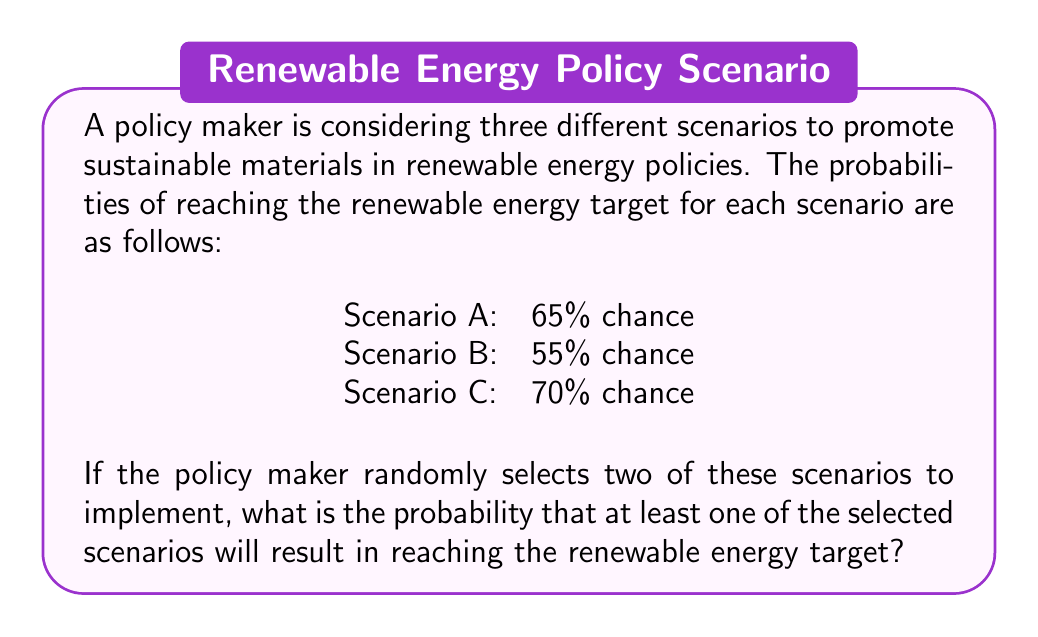Teach me how to tackle this problem. To solve this problem, we need to use the concept of probability of at least one event occurring.

1. First, let's calculate the probability of failure for each scenario:
   Scenario A: $1 - 0.65 = 0.35$
   Scenario B: $1 - 0.55 = 0.45$
   Scenario C: $1 - 0.70 = 0.30$

2. There are three possible combinations of two scenarios:
   A and B, A and C, B and C

3. For each combination, we calculate the probability that both scenarios fail:
   A and B: $0.35 \times 0.45 = 0.1575$
   A and C: $0.35 \times 0.30 = 0.1050$
   B and C: $0.45 \times 0.30 = 0.1350$

4. The probability of selecting each combination is $\frac{1}{3}$, so we calculate the weighted average:

   $$P(\text{both fail}) = \frac{1}{3}(0.1575 + 0.1050 + 0.1350) = 0.1325$$

5. The probability of at least one scenario succeeding is the complement of both failing:

   $$P(\text{at least one succeeds}) = 1 - P(\text{both fail}) = 1 - 0.1325 = 0.8675$$

Therefore, the probability of at least one of the selected scenarios reaching the renewable energy target is 0.8675 or 86.75%.
Answer: The probability that at least one of the two randomly selected scenarios will result in reaching the renewable energy target is 0.8675 or 86.75%. 